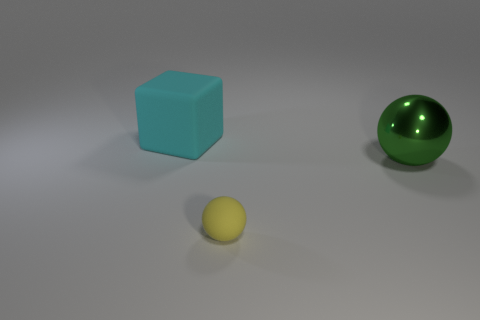Are there any other things that are the same material as the large green ball?
Make the answer very short. No. What color is the tiny object that is the same material as the big cyan thing?
Your response must be concise. Yellow. What number of cyan blocks are the same size as the yellow thing?
Ensure brevity in your answer.  0. What is the block made of?
Ensure brevity in your answer.  Rubber. Are there more matte objects than tiny matte spheres?
Ensure brevity in your answer.  Yes. Is the shape of the shiny object the same as the small yellow rubber object?
Your response must be concise. Yes. Is there anything else that is the same shape as the cyan object?
Keep it short and to the point. No. Is the number of rubber objects in front of the small rubber ball less than the number of rubber objects that are to the right of the cube?
Your answer should be compact. Yes. There is a object that is in front of the green thing; what is its shape?
Offer a very short reply. Sphere. What number of other things are the same material as the large cyan cube?
Provide a short and direct response. 1. 